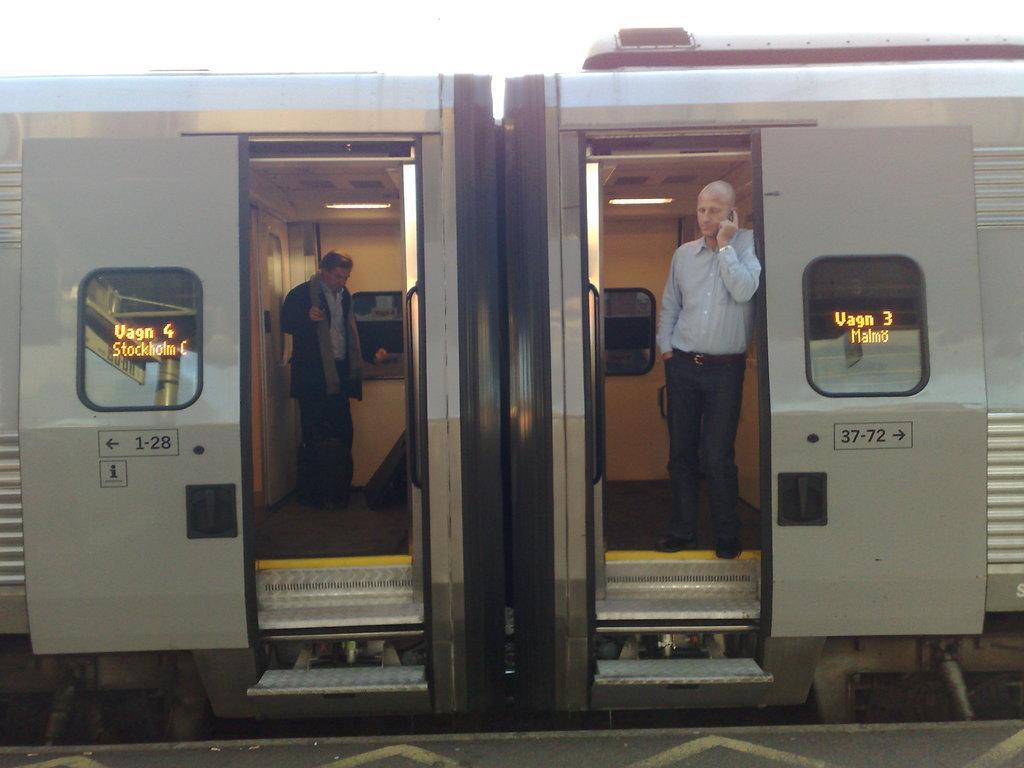Describe this image in one or two sentences. In this picture we can see there are two persons in a vehicle. On the vehicles, there are windows, numbers and arrow symbols. 